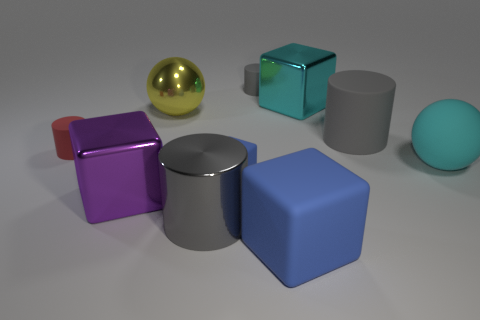Subtract all yellow balls. How many gray cylinders are left? 3 Subtract all small red cylinders. How many cylinders are left? 3 Subtract all cyan cubes. How many cubes are left? 3 Subtract all brown blocks. Subtract all brown cylinders. How many blocks are left? 4 Subtract all spheres. How many objects are left? 8 Add 8 large metal blocks. How many large metal blocks exist? 10 Subtract 0 green cubes. How many objects are left? 10 Subtract all small things. Subtract all large cyan rubber things. How many objects are left? 6 Add 4 gray rubber objects. How many gray rubber objects are left? 6 